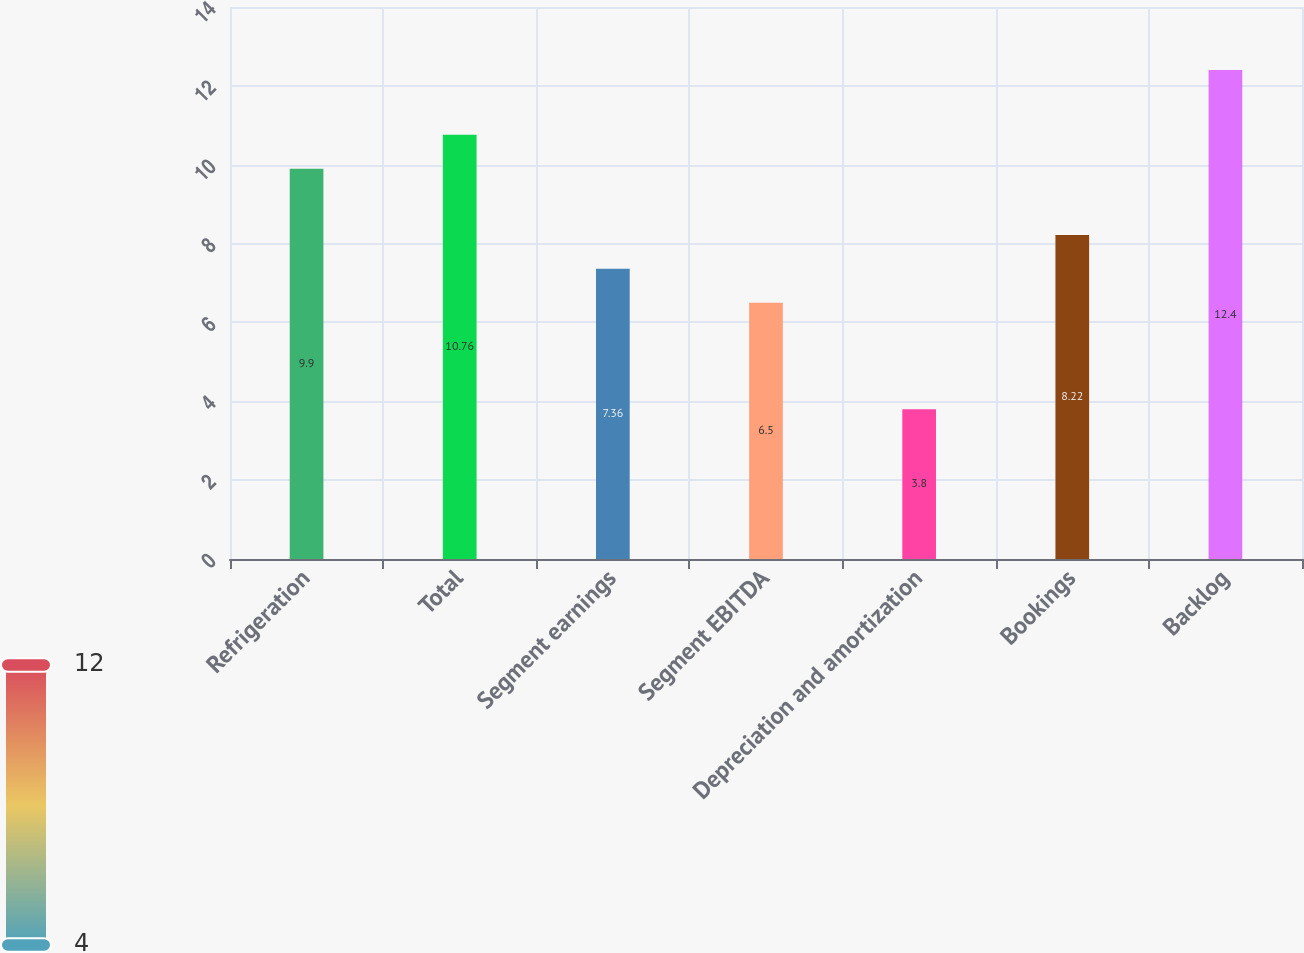Convert chart. <chart><loc_0><loc_0><loc_500><loc_500><bar_chart><fcel>Refrigeration<fcel>Total<fcel>Segment earnings<fcel>Segment EBITDA<fcel>Depreciation and amortization<fcel>Bookings<fcel>Backlog<nl><fcel>9.9<fcel>10.76<fcel>7.36<fcel>6.5<fcel>3.8<fcel>8.22<fcel>12.4<nl></chart> 